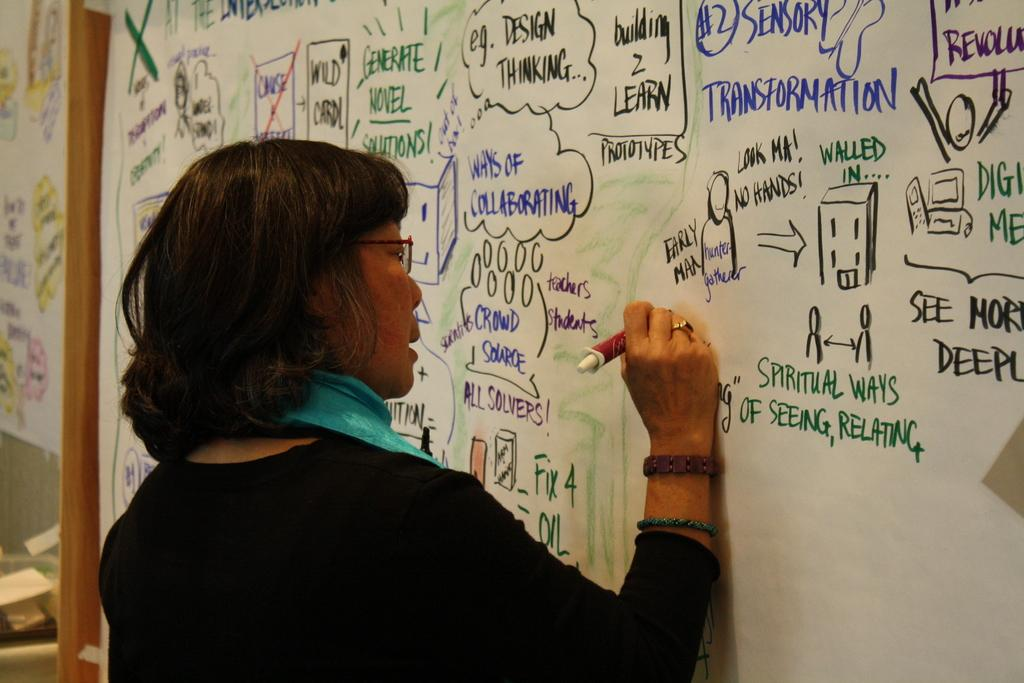<image>
Relay a brief, clear account of the picture shown. A woman is writing on a white board, which already says "spiritual ways of seeing, relating." 